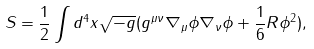Convert formula to latex. <formula><loc_0><loc_0><loc_500><loc_500>S = \frac { 1 } { 2 } \int d ^ { 4 } x \sqrt { - g } ( g ^ { \mu \nu } \nabla _ { \mu } \phi \nabla _ { \nu } \phi + \frac { 1 } { 6 } R \phi ^ { 2 } ) ,</formula> 